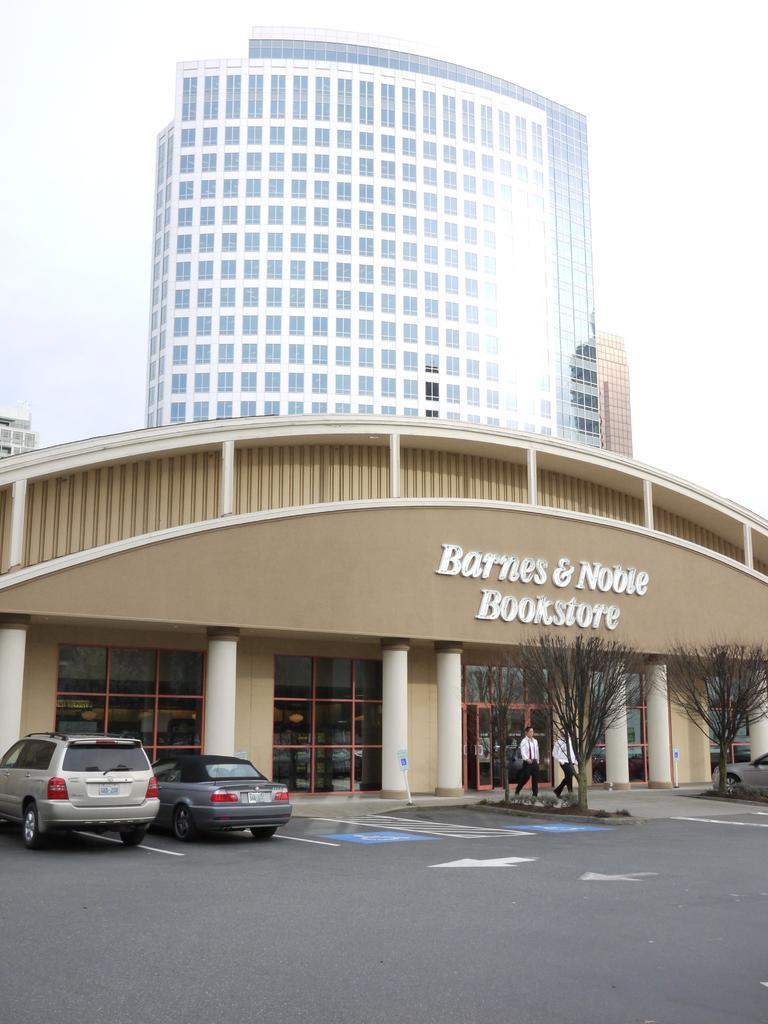Could you give a brief overview of what you see in this image? In this picture we can see vehicles on the road, trees, pillars, buildings with windows and two people are walking on the ground and in the background we can see the sky. 